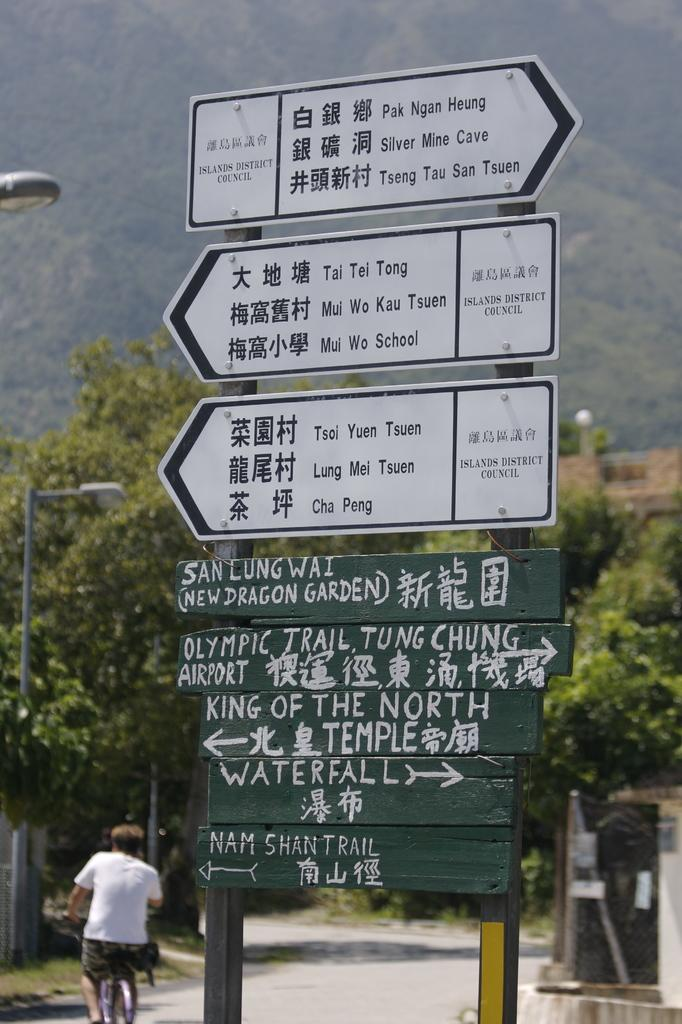What is located in the center of the image? There are sign boards in the center of the image. What can be seen on the left side of the image? There are poles on the left side of the image. What activity is being performed by a person in the image? A person is riding a bicycle at the bottom of the image. What type of natural scenery is visible in the background of the image? There are trees in the background of the image. Can you tell me how many seeds are scattered on the ground in the image? There are no seeds visible in the image; it features sign boards, poles, a person riding a bicycle, and trees in the background. What type of wire is being used by the person riding the bicycle in the image? There is no wire present in the image; the person is riding a bicycle without any visible wires. 